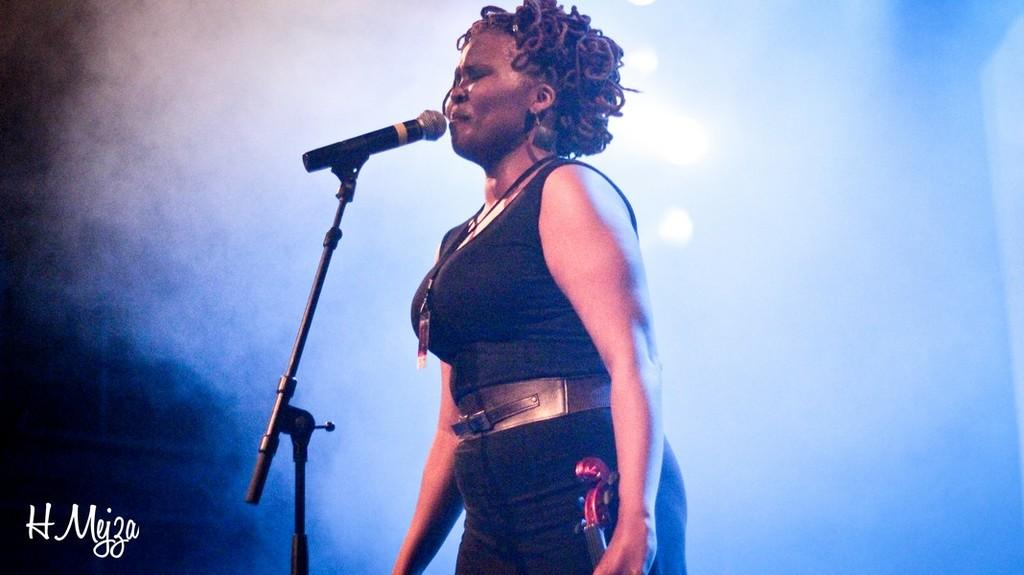What is the person in the image doing? The person is standing in front of a mic. What is the person wearing? The person is wearing a dress. What can be seen in the background of the image? There is smoke in the background of the image. Is there any additional information or branding present in the image? Yes, there is a watermark in the image. What type of paper is the laborer using to gain experience in the image? There is no laborer or paper present in the image, and no experience-related activities are depicted. 